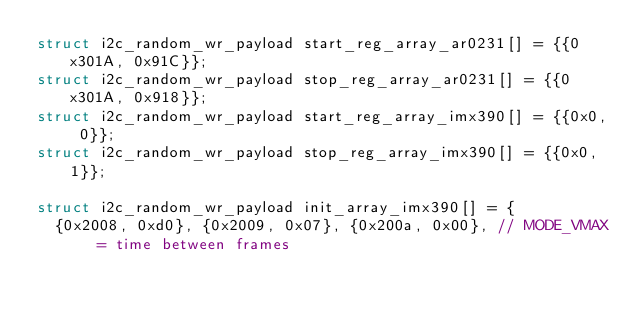<code> <loc_0><loc_0><loc_500><loc_500><_C_>struct i2c_random_wr_payload start_reg_array_ar0231[] = {{0x301A, 0x91C}};
struct i2c_random_wr_payload stop_reg_array_ar0231[] = {{0x301A, 0x918}};
struct i2c_random_wr_payload start_reg_array_imx390[] = {{0x0, 0}};
struct i2c_random_wr_payload stop_reg_array_imx390[] = {{0x0, 1}};

struct i2c_random_wr_payload init_array_imx390[] = {
  {0x2008, 0xd0}, {0x2009, 0x07}, {0x200a, 0x00}, // MODE_VMAX = time between frames</code> 